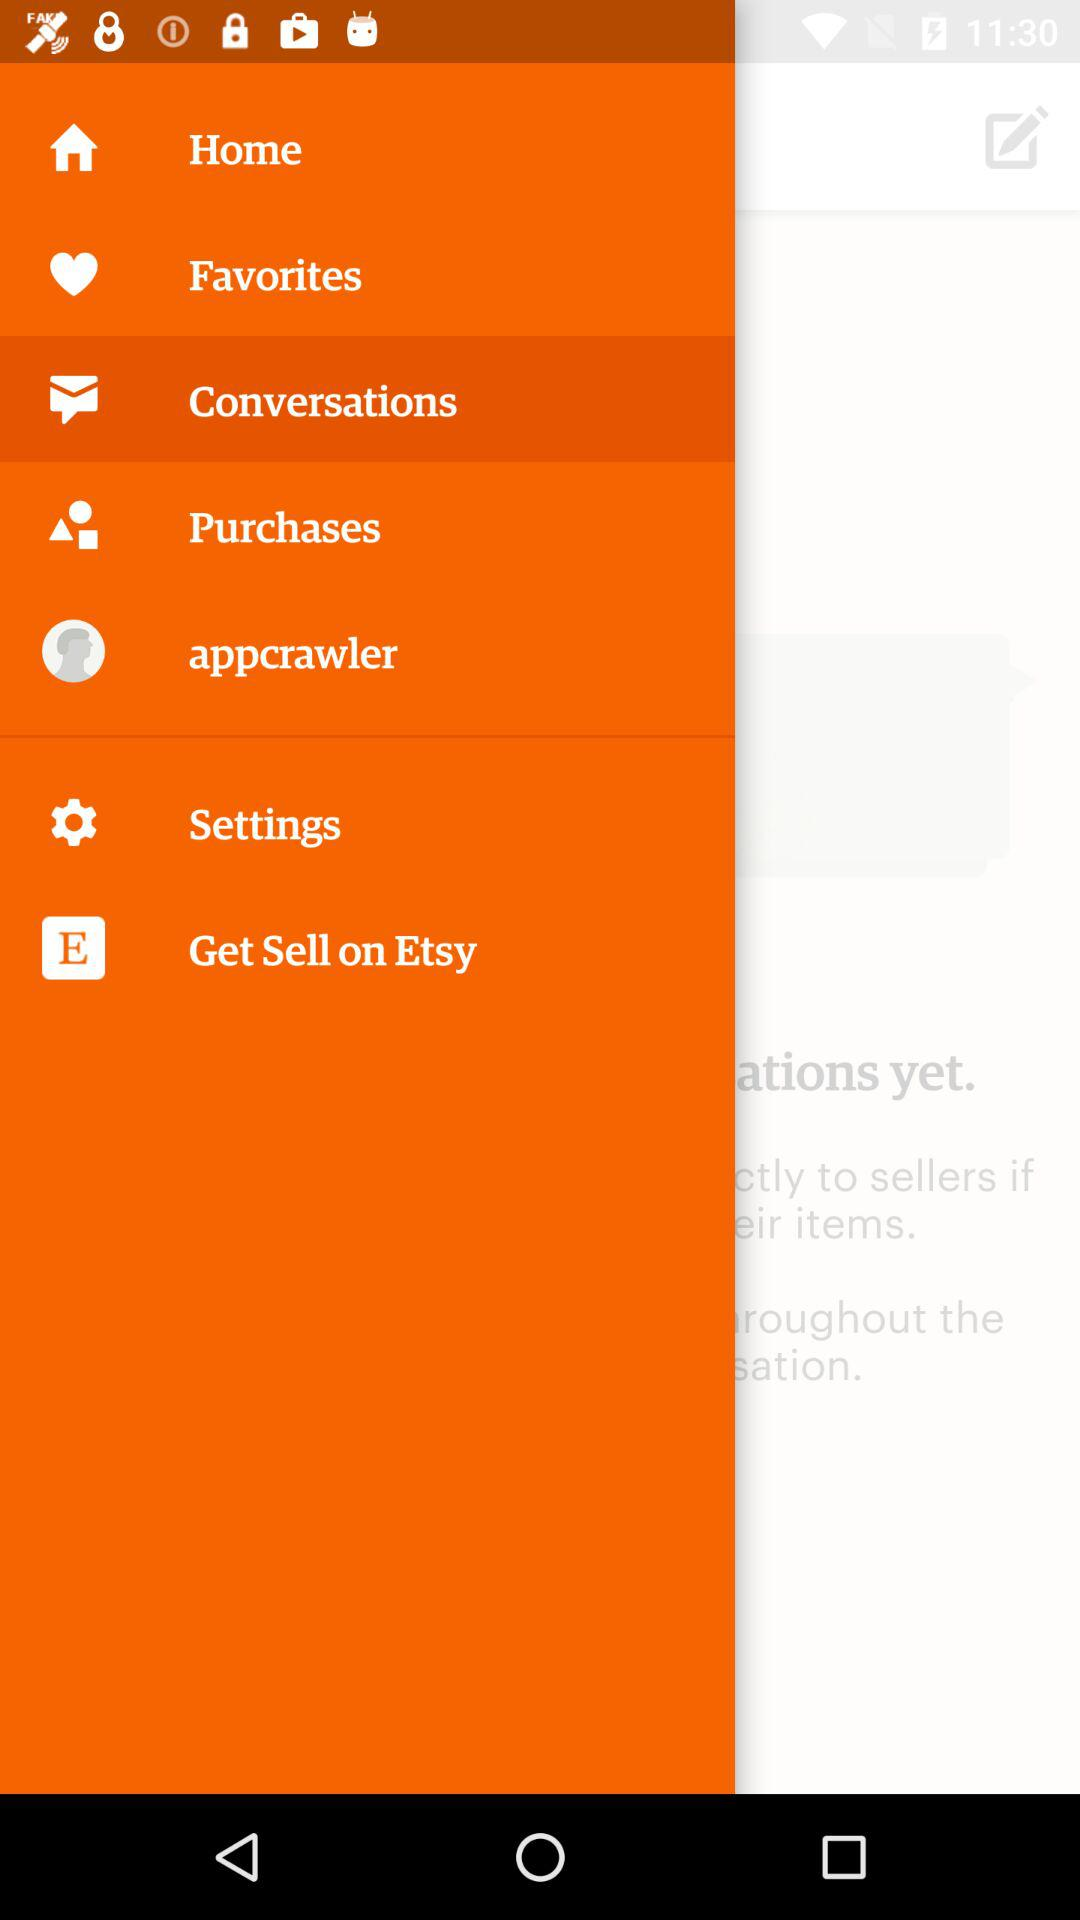Which item has been selected? The selected item is "Conversations". 